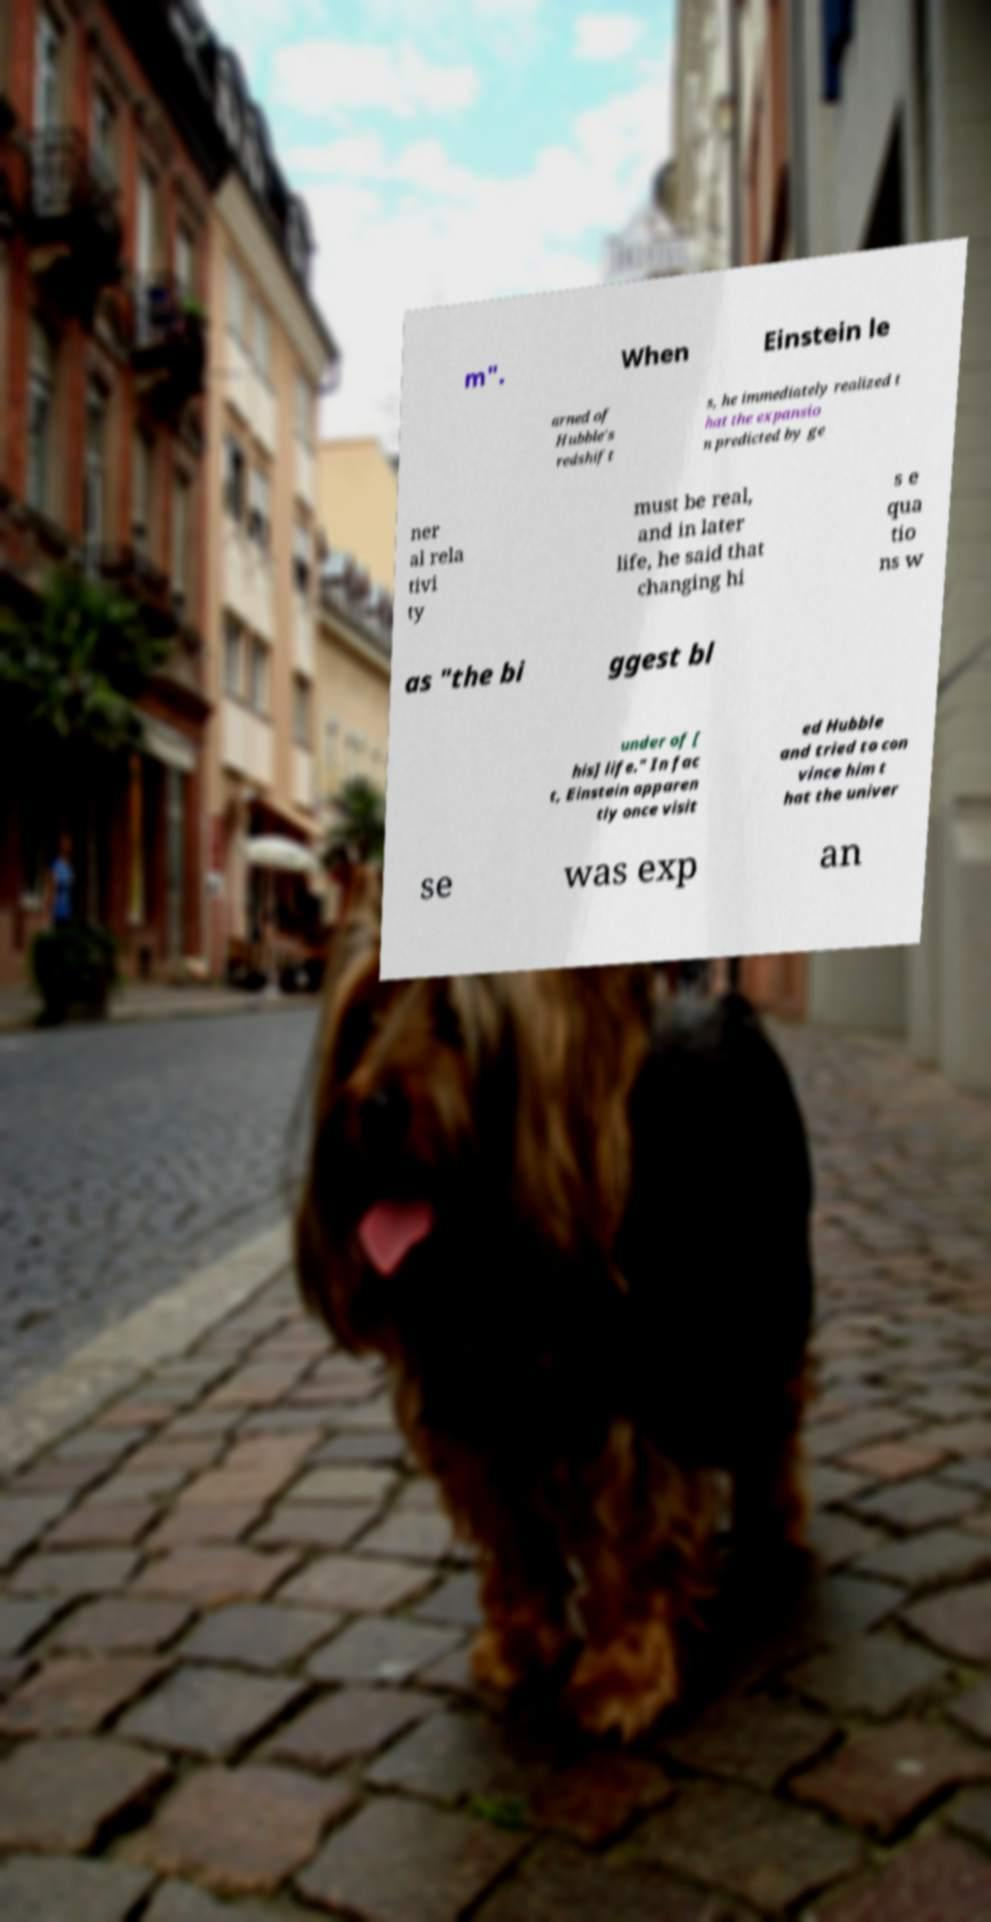There's text embedded in this image that I need extracted. Can you transcribe it verbatim? m". When Einstein le arned of Hubble's redshift s, he immediately realized t hat the expansio n predicted by ge ner al rela tivi ty must be real, and in later life, he said that changing hi s e qua tio ns w as "the bi ggest bl under of [ his] life." In fac t, Einstein apparen tly once visit ed Hubble and tried to con vince him t hat the univer se was exp an 